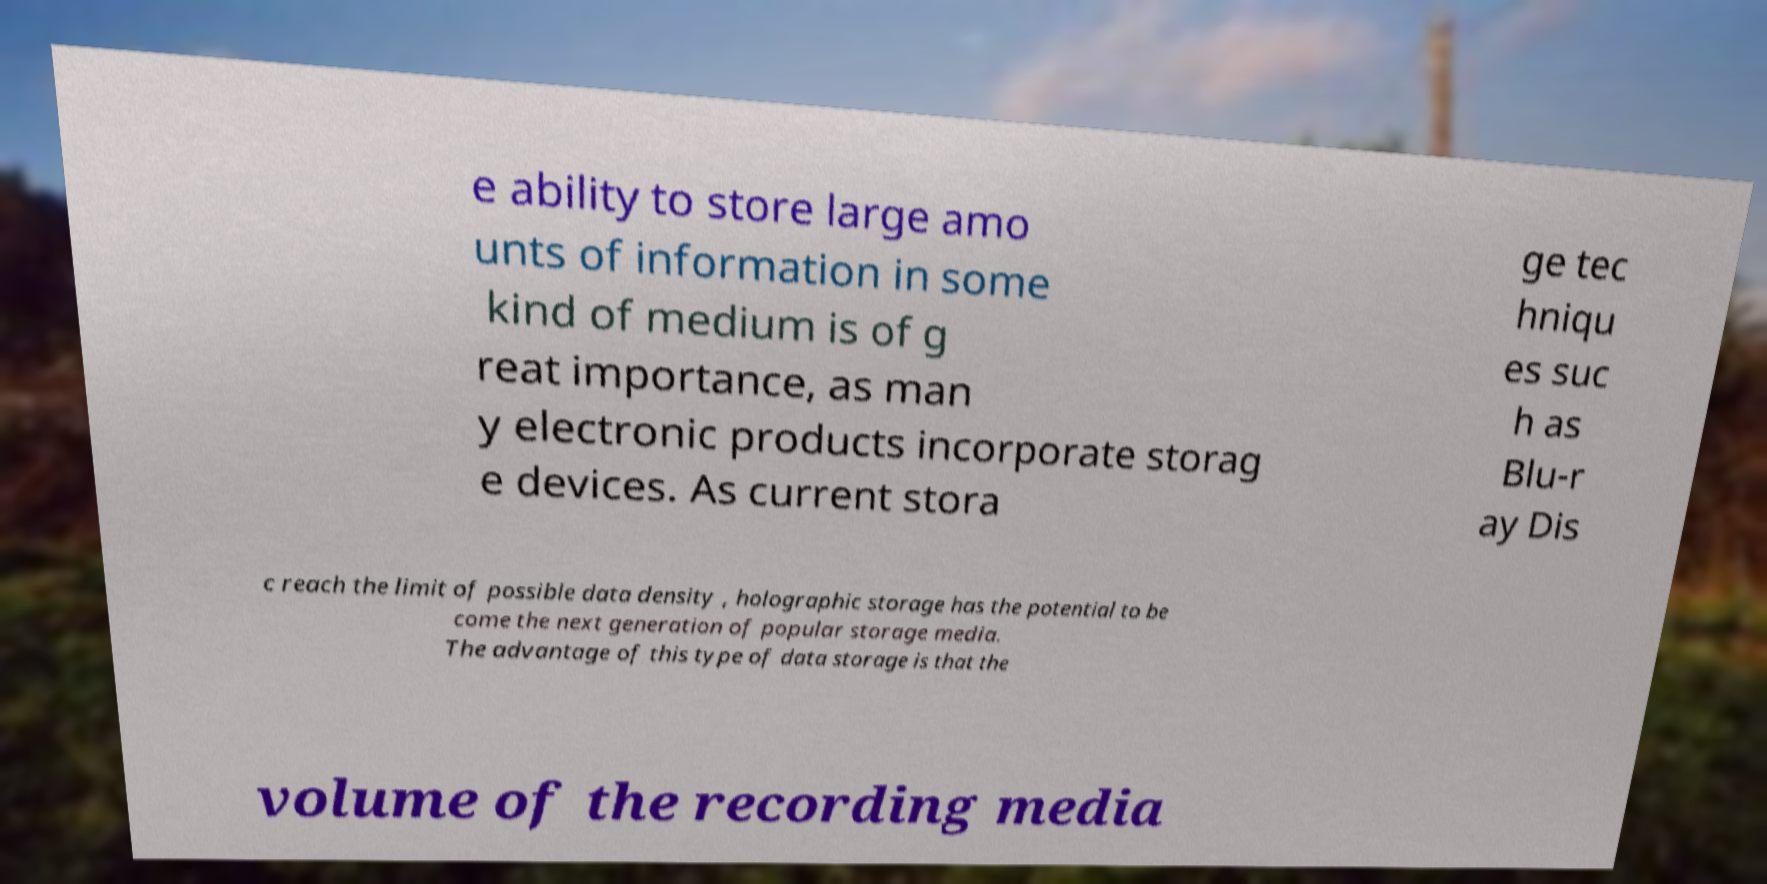Please read and relay the text visible in this image. What does it say? e ability to store large amo unts of information in some kind of medium is of g reat importance, as man y electronic products incorporate storag e devices. As current stora ge tec hniqu es suc h as Blu-r ay Dis c reach the limit of possible data density , holographic storage has the potential to be come the next generation of popular storage media. The advantage of this type of data storage is that the volume of the recording media 